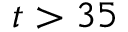<formula> <loc_0><loc_0><loc_500><loc_500>t > 3 5</formula> 